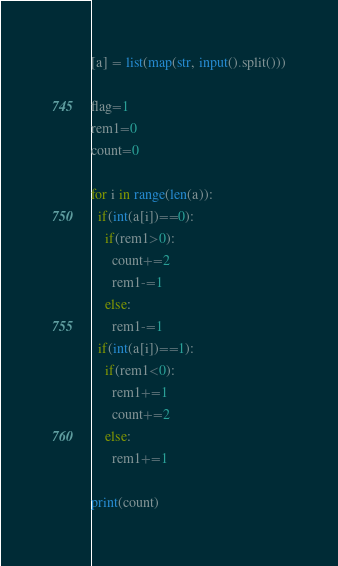Convert code to text. <code><loc_0><loc_0><loc_500><loc_500><_Python_>[a] = list(map(str, input().split()))

flag=1
rem1=0
count=0

for i in range(len(a)):
  if(int(a[i])==0):
    if(rem1>0):
      count+=2
      rem1-=1
    else:
      rem1-=1
  if(int(a[i])==1):
    if(rem1<0):
      rem1+=1
      count+=2
    else:
      rem1+=1

print(count)</code> 